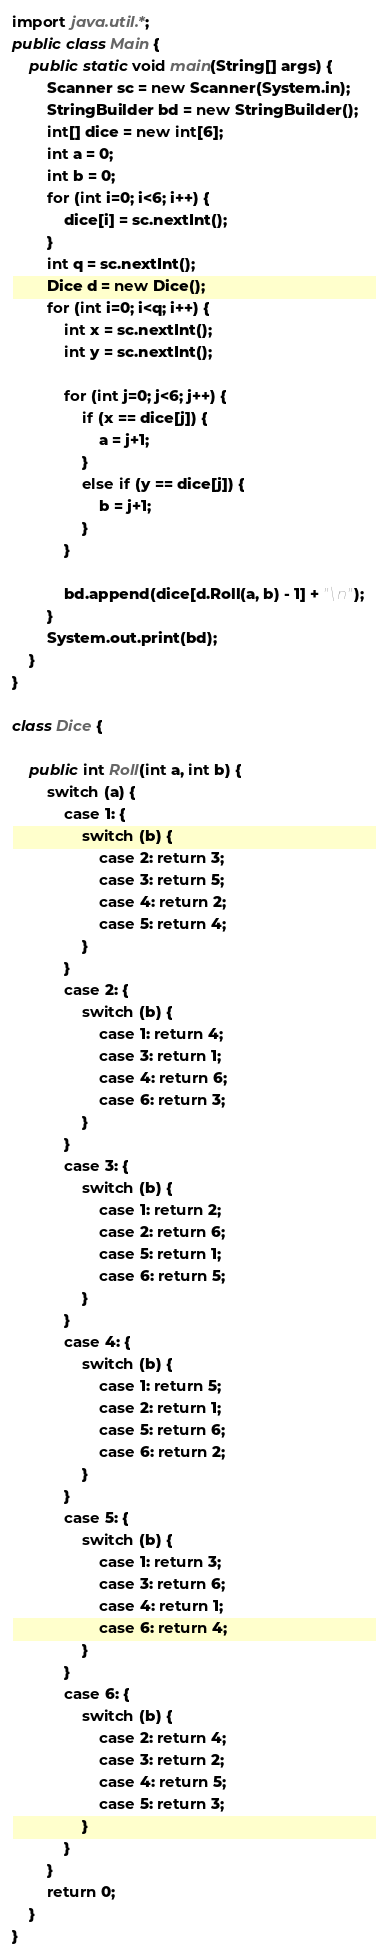Convert code to text. <code><loc_0><loc_0><loc_500><loc_500><_Java_>import java.util.*;
public class Main {
    public static void main(String[] args) {
        Scanner sc = new Scanner(System.in);
        StringBuilder bd = new StringBuilder();
        int[] dice = new int[6];
        int a = 0;
        int b = 0;
        for (int i=0; i<6; i++) {
            dice[i] = sc.nextInt();
        }
        int q = sc.nextInt();
        Dice d = new Dice();
        for (int i=0; i<q; i++) {
            int x = sc.nextInt();
            int y = sc.nextInt();

            for (int j=0; j<6; j++) {
                if (x == dice[j]) {
                    a = j+1;
                }
                else if (y == dice[j]) {
                    b = j+1;
                }
            }

            bd.append(dice[d.Roll(a, b) - 1] + "\n");
        }
        System.out.print(bd);
    }
}

class Dice {

    public int Roll(int a, int b) {
        switch (a) {
            case 1: {
                switch (b) {
                    case 2: return 3;
                    case 3: return 5;
                    case 4: return 2;
                    case 5: return 4;
                }
            }
            case 2: {
                switch (b) {
                    case 1: return 4;
                    case 3: return 1;
                    case 4: return 6;
                    case 6: return 3;
                }
            }
            case 3: {
                switch (b) {
                    case 1: return 2;
                    case 2: return 6;
                    case 5: return 1;
                    case 6: return 5;
                }
            }
            case 4: {
                switch (b) {
                    case 1: return 5;
                    case 2: return 1;
                    case 5: return 6;
                    case 6: return 2;
                }
            }
            case 5: {
                switch (b) {
                    case 1: return 3;
                    case 3: return 6;
                    case 4: return 1;
                    case 6: return 4;
                }
            }
            case 6: {
                switch (b) {
                    case 2: return 4;
                    case 3: return 2;
                    case 4: return 5;
                    case 5: return 3;
                }
            }
        }
        return 0;
    }
}
</code> 